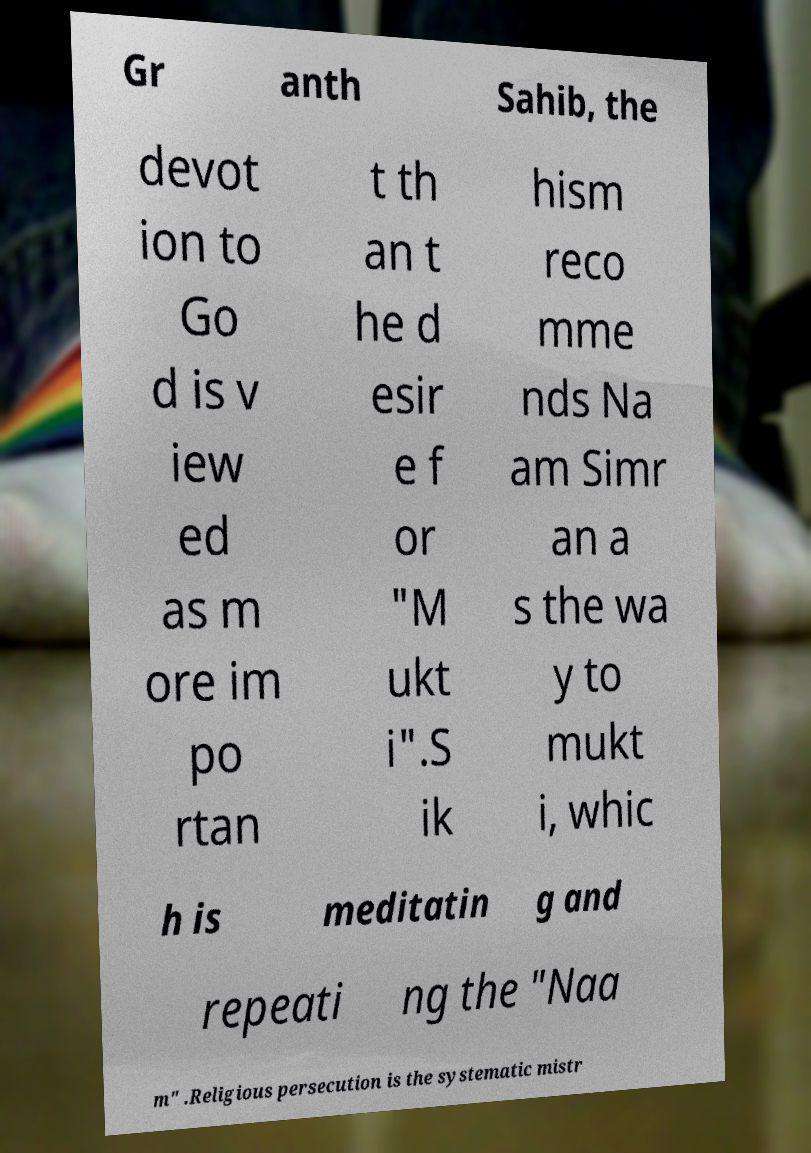Could you assist in decoding the text presented in this image and type it out clearly? Gr anth Sahib, the devot ion to Go d is v iew ed as m ore im po rtan t th an t he d esir e f or "M ukt i".S ik hism reco mme nds Na am Simr an a s the wa y to mukt i, whic h is meditatin g and repeati ng the "Naa m" .Religious persecution is the systematic mistr 